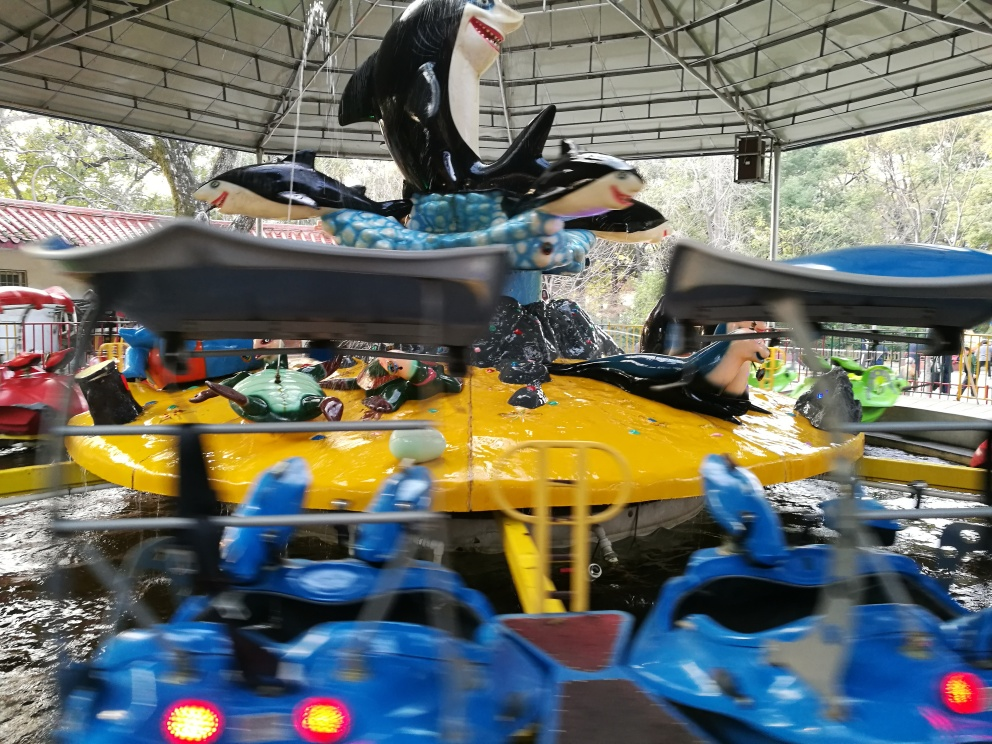What type of attraction is shown in this image? The image depicts a carousel, which is a rotating amusement ride with seats for riders. The seats are modeled after various sea creatures, and there's also a large penguin figure at the center, indicating a water or ocean theme. 